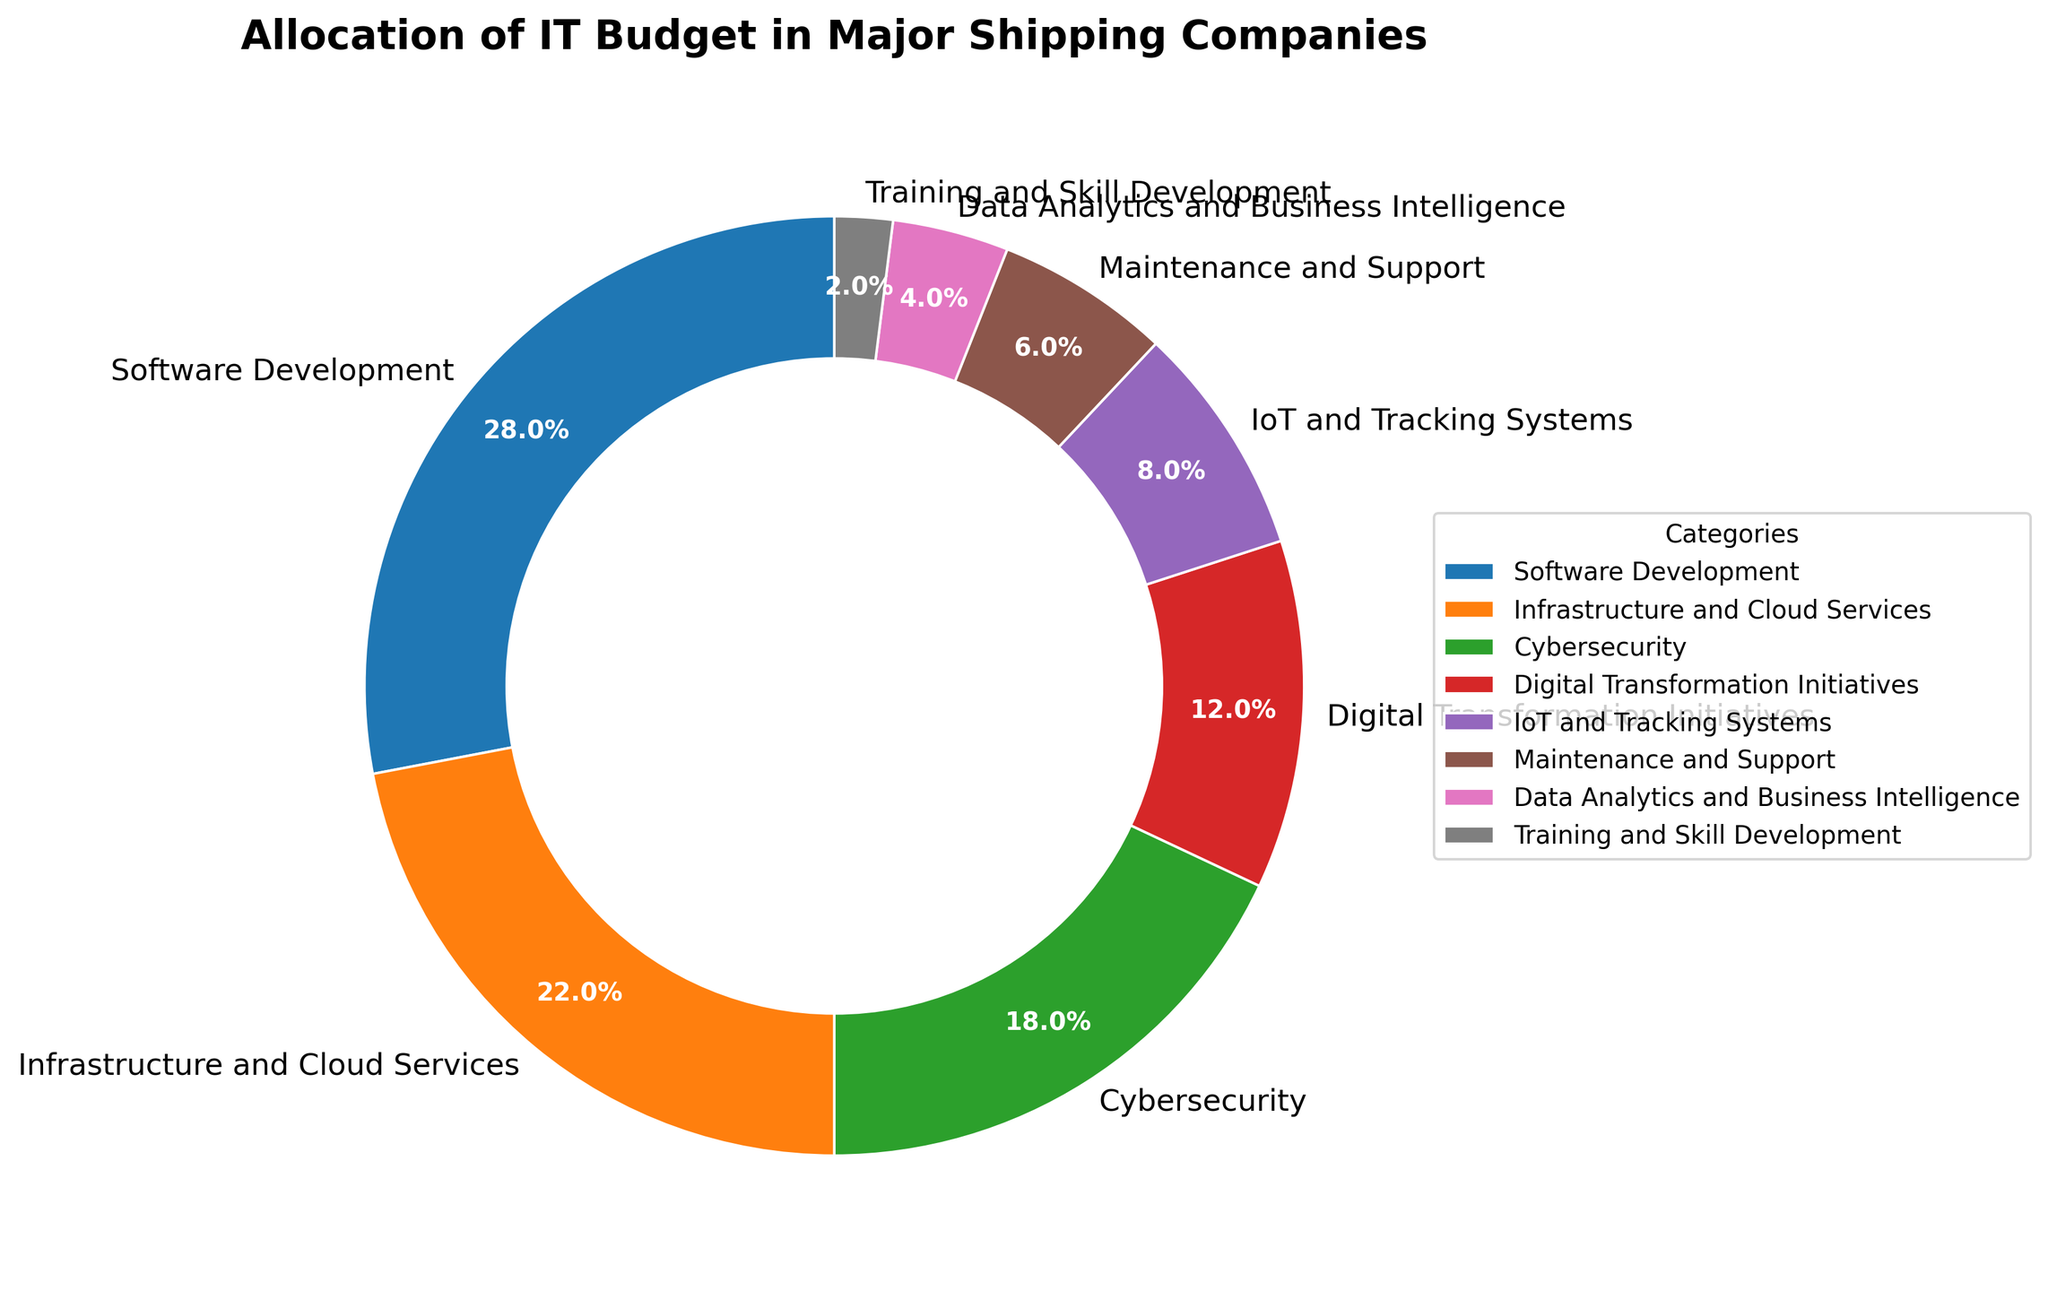What is the largest category in the IT budget allocation? The largest category is the one with the highest percentage slice in the pie chart. From the figure, Software Development has 28%, which is the largest.
Answer: Software Development What two categories combined equal the same percentage as Cybersecurity? Cybersecurity has 18%. The two categories that sum up to 18% are IoT and Tracking Systems (8%) and Maintenance and Support (6%) because 8% + 6% = 14%, and further including Training and Skill Development (2%) gives us a total of 14% + 2% = 16%, which is lower. Thus, the only option left that matches is Infrastructure and Cloud Services (22%) and Digital Transformation Initiatives (12%), but this exceeds 18%. There is no exact match with the current allocation percentages.
Answer: No exact match Which category is allocated more budget, Infrastructure and Cloud Services or Cybersecurity? Compare the percentages of the two categories. Infrastructure and Cloud Services has 22%, and Cybersecurity has 18%.
Answer: Infrastructure and Cloud Services How much more budget percentage is allocated to IoT and Tracking Systems compared to Data Analytics and Business Intelligence? IoT and Tracking Systems is 8%, and Data Analytics and Business Intelligence is 4%. The difference is calculated as 8% - 4%.
Answer: 4% What is the total budget percentage allocated to the bottom three categories? Sum the percentages of the three smallest categories: Maintenance and Support (6%), Data Analytics and Business Intelligence (4%), and Training and Skill Development (2%). The calculation step is 6% + 4% + 2%.
Answer: 12% Which category is depicted with the smallest slice in the pie chart? The category with the smallest percentage gets the smallest slice. Training and Skill Development is allocated 2%, which is the smallest.
Answer: Training and Skill Development Is the budget allocation for Digital Transformation Initiatives greater than the sum of Data Analytics and Business Intelligence and Training and Skill Development? Digital Transformation Initiatives is 12%. Data Analytics and Business Intelligence (4%) plus Training and Skill Development (2%) sums to 6%. 12% is greater than 6%.
Answer: Yes What percentage of the budget is dedicated to non-development activities (excluding Software Development and Maintenance and Support)? Sum the percentages of all other categories excluding Software Development (28%) and Maintenance and Support (6%): 22% (Infrastructure and Cloud Services) + 18% (Cybersecurity) + 12% (Digital Transformation Initiatives) + 8% (IoT and Tracking Systems) + 4% (Data Analytics and Business Intelligence) + 2% (Training and Skill Development). The calculation is 22% + 18% + 12% + 8% + 4% + 2%.
Answer: 66% By how much does the Cybersecurity budget allocation exceed the sum of IoT and Tracking Systems and Training and Skill Development? Cybersecurity is 18%. IoT and Tracking Systems (8%) plus Training and Skill Development (2%) sums to 10%. The difference is calculated as 18% - 10%.
Answer: 8% 